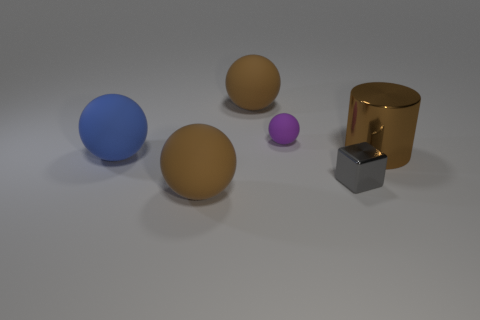Are there an equal number of gray blocks that are on the left side of the big blue object and rubber cylinders?
Provide a succinct answer. Yes. There is a metallic cylinder; how many tiny metal cubes are to the right of it?
Offer a very short reply. 0. What size is the blue rubber ball?
Provide a short and direct response. Large. There is a small thing that is made of the same material as the brown cylinder; what is its color?
Make the answer very short. Gray. How many other things are the same size as the gray metal thing?
Your response must be concise. 1. Is the big brown thing behind the purple rubber ball made of the same material as the big cylinder?
Make the answer very short. No. Is the number of tiny purple matte things in front of the purple object less than the number of small purple matte objects?
Your answer should be very brief. Yes. The large brown thing that is behind the large brown metal thing has what shape?
Provide a succinct answer. Sphere. There is a purple rubber thing that is the same size as the gray thing; what is its shape?
Your answer should be very brief. Sphere. Are there any gray rubber things that have the same shape as the purple rubber thing?
Make the answer very short. No. 